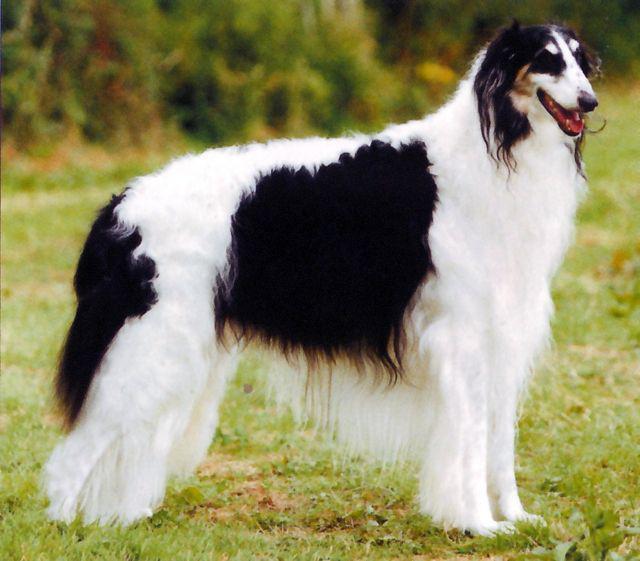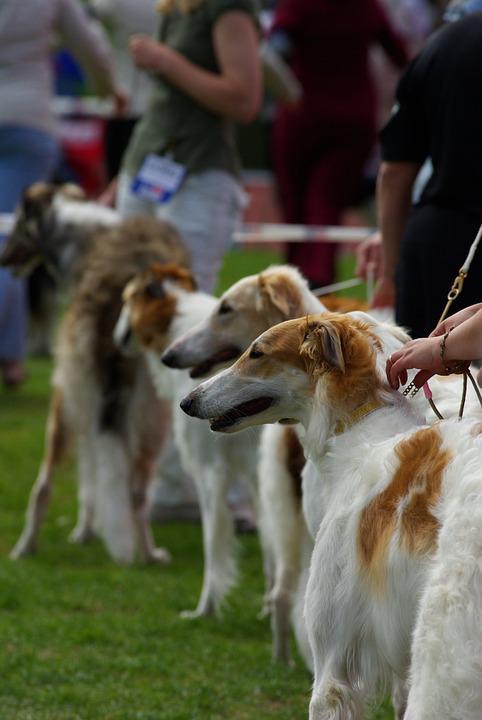The first image is the image on the left, the second image is the image on the right. For the images shown, is this caption "All hounds shown are trotting on a green surface, and one of the dogs is trotting leftward alongside a person on green carpet." true? Answer yes or no. No. The first image is the image on the left, the second image is the image on the right. For the images shown, is this caption "One of the dogs is on artificial turf." true? Answer yes or no. No. 